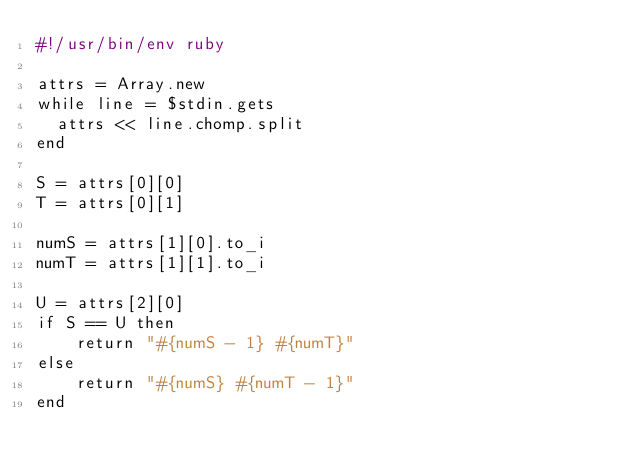Convert code to text. <code><loc_0><loc_0><loc_500><loc_500><_Ruby_>#!/usr/bin/env ruby

attrs = Array.new
while line = $stdin.gets
  attrs << line.chomp.split
end

S = attrs[0][0]
T = attrs[0][1]

numS = attrs[1][0].to_i
numT = attrs[1][1].to_i

U = attrs[2][0]
if S == U then
    return "#{numS - 1} #{numT}"
else
    return "#{numS} #{numT - 1}"
end</code> 